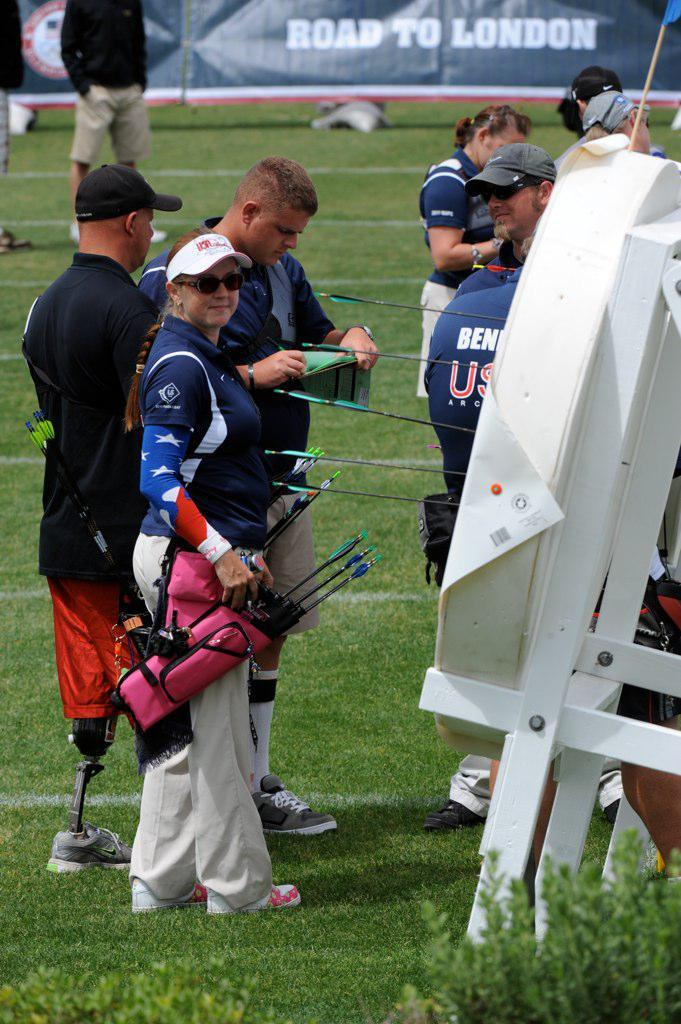<image>
Write a terse but informative summary of the picture. Road to London archery contest with several people standing around. 